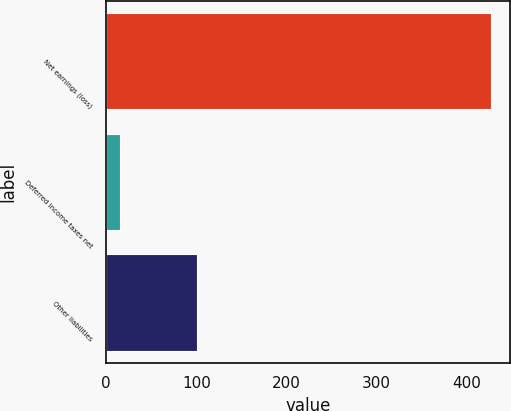<chart> <loc_0><loc_0><loc_500><loc_500><bar_chart><fcel>Net earnings (loss)<fcel>Deferred income taxes net<fcel>Other liabilities<nl><fcel>427<fcel>15<fcel>101<nl></chart> 